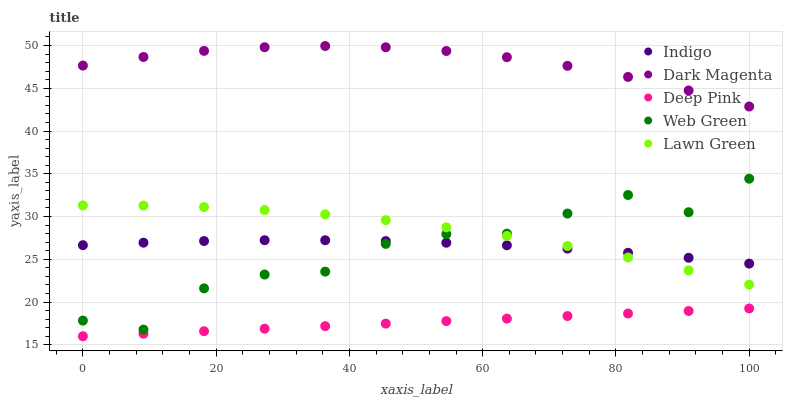Does Deep Pink have the minimum area under the curve?
Answer yes or no. Yes. Does Dark Magenta have the maximum area under the curve?
Answer yes or no. Yes. Does Indigo have the minimum area under the curve?
Answer yes or no. No. Does Indigo have the maximum area under the curve?
Answer yes or no. No. Is Deep Pink the smoothest?
Answer yes or no. Yes. Is Web Green the roughest?
Answer yes or no. Yes. Is Indigo the smoothest?
Answer yes or no. No. Is Indigo the roughest?
Answer yes or no. No. Does Deep Pink have the lowest value?
Answer yes or no. Yes. Does Indigo have the lowest value?
Answer yes or no. No. Does Dark Magenta have the highest value?
Answer yes or no. Yes. Does Indigo have the highest value?
Answer yes or no. No. Is Indigo less than Dark Magenta?
Answer yes or no. Yes. Is Dark Magenta greater than Deep Pink?
Answer yes or no. Yes. Does Web Green intersect Indigo?
Answer yes or no. Yes. Is Web Green less than Indigo?
Answer yes or no. No. Is Web Green greater than Indigo?
Answer yes or no. No. Does Indigo intersect Dark Magenta?
Answer yes or no. No. 